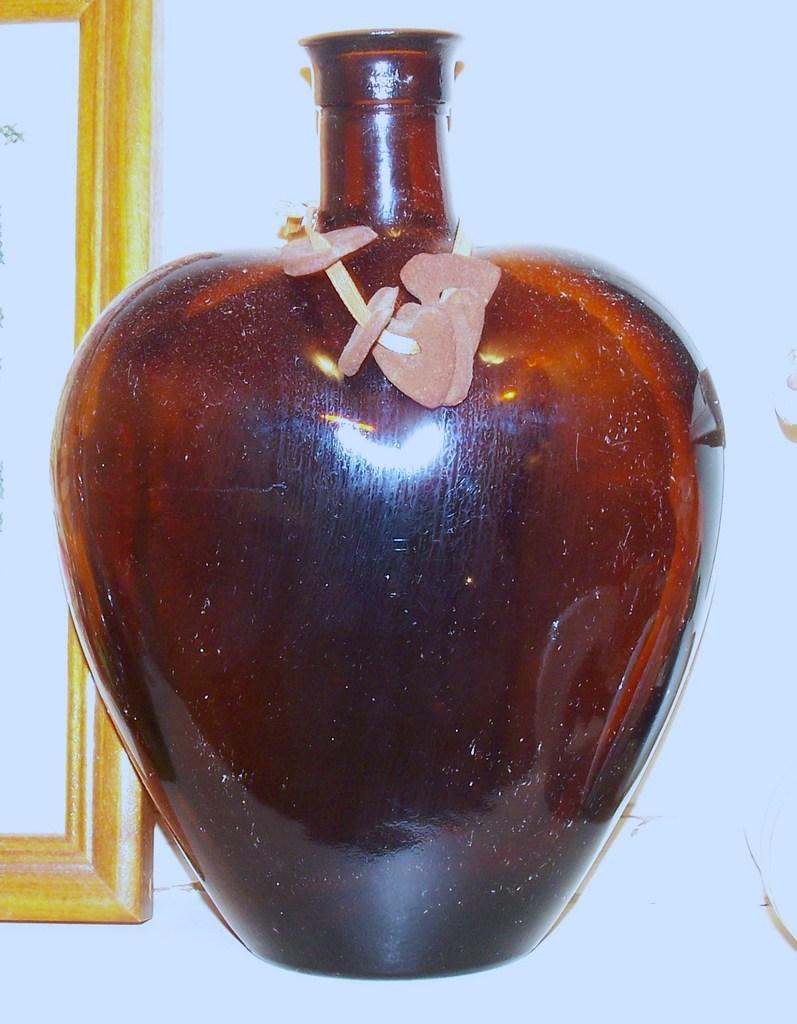Can you describe this image briefly? In this image there is a glass bottle in the middle. On the left side there is a frame. On the glass bottle there are some flowers. 